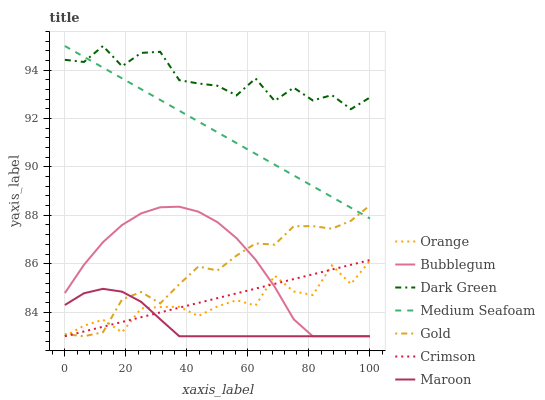Does Maroon have the minimum area under the curve?
Answer yes or no. Yes. Does Dark Green have the maximum area under the curve?
Answer yes or no. Yes. Does Bubblegum have the minimum area under the curve?
Answer yes or no. No. Does Bubblegum have the maximum area under the curve?
Answer yes or no. No. Is Crimson the smoothest?
Answer yes or no. Yes. Is Dark Green the roughest?
Answer yes or no. Yes. Is Bubblegum the smoothest?
Answer yes or no. No. Is Bubblegum the roughest?
Answer yes or no. No. Does Medium Seafoam have the lowest value?
Answer yes or no. No. Does Dark Green have the highest value?
Answer yes or no. Yes. Does Bubblegum have the highest value?
Answer yes or no. No. Is Crimson less than Medium Seafoam?
Answer yes or no. Yes. Is Dark Green greater than Gold?
Answer yes or no. Yes. Does Orange intersect Crimson?
Answer yes or no. Yes. Is Orange less than Crimson?
Answer yes or no. No. Is Orange greater than Crimson?
Answer yes or no. No. Does Crimson intersect Medium Seafoam?
Answer yes or no. No. 